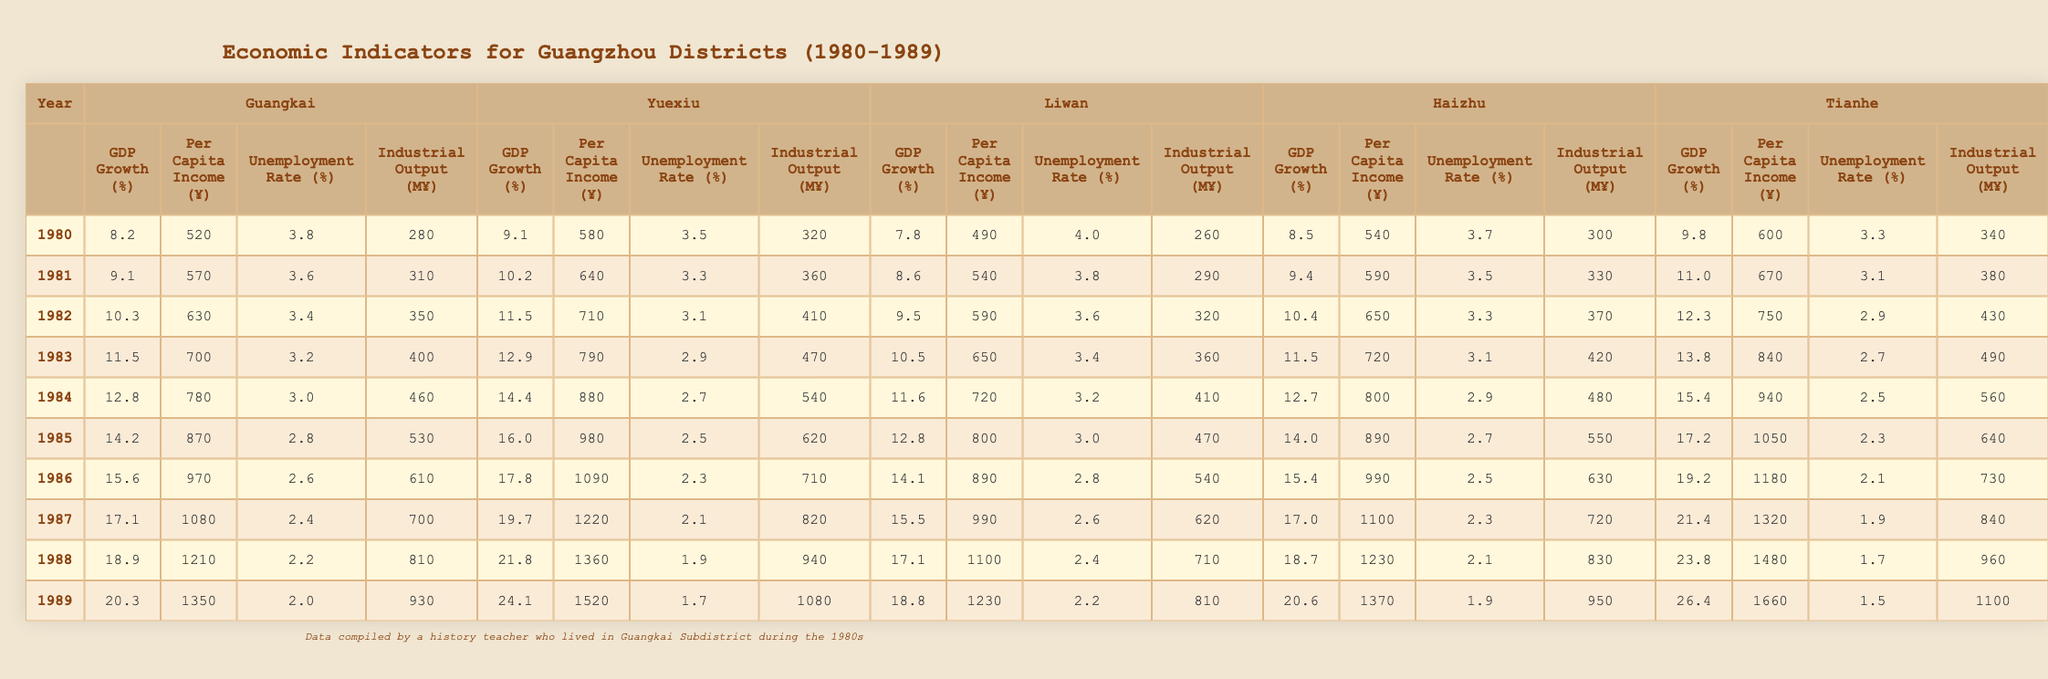What was the GDP growth rate in Guangkai in 1985? In the row for 1985 under Guangkai, the GDP growth rate listed is 14.2%.
Answer: 14.2% Which district had the highest per capita income in 1989? In 1989, the per capita income for each district shows Tianhe at ¥1660, which is higher than all other districts listed for that year.
Answer: Tianhe How much did Guangkai's industrial output increase from 1980 to 1989? The industrial output in 1980 was 280 million yuan and in 1989 it was 930 million yuan. The increase is calculated as 930 - 280 = 650 million yuan.
Answer: 650 million yuan Which district had a lower unemployment rate in 1987, Guangkai or Liwan? In 1987, Guangkai had an unemployment rate of 2.4% and Liwan had 2.6%. Since 2.4% is less than 2.6%, Guangkai had a lower unemployment rate.
Answer: Guangkai What was the average GDP growth rate for Guangkai over the 1980s? To find the average, we sum the GDP growth rates from 1980 to 1989: (8.2 + 9.1 + 10.3 + 11.5 + 12.8 + 14.2 + 15.6 + 17.1 + 18.9 + 20.3) =  127.9%. Dividing by the number of years (10) gives an average of 12.79%.
Answer: 12.79% Did Yuexiu have a higher unemployment rate than Tianhe in 1986? The unemployment rate in Yuexiu for 1986 was 2.6% while Tianhe had 2.1%. Since 2.6% is higher than 2.1%, the answer is yes.
Answer: Yes In what year did Liwan's per capita income first exceed ¥800? In the table, Liwan's per capita income exceeded ¥800 for the first time in 1985, when it was ¥800.
Answer: 1985 Which district had the highest GDP growth rate in 1988? Looking at the GDP growth rates for each district in 1988, Tianhe had the highest rate at 23.8%.
Answer: Tianhe How much higher was Haizhu's per capita income than Liwan's in 1989? In 1989, Haizhu's per capita income was ¥1370 and Liwan's was ¥1230. The difference is calculated as 1370 - 1230 = ¥140.
Answer: ¥140 What was the unemployment rate trend in Guangkai from 1980 to 1989? The unemployment rate in Guangkai decreased steadily from 3.8% in 1980 to 2.0% in 1989. This indicates a downward trend over the decade.
Answer: Decreasing Which two districts had the closest industrial output in 1984? In 1984, Guangkai had an industrial output of 460 million yuan and Liwan had 410 million yuan. The difference of 50 million yuan indicates they were close in output.
Answer: Guangkai and Liwan 